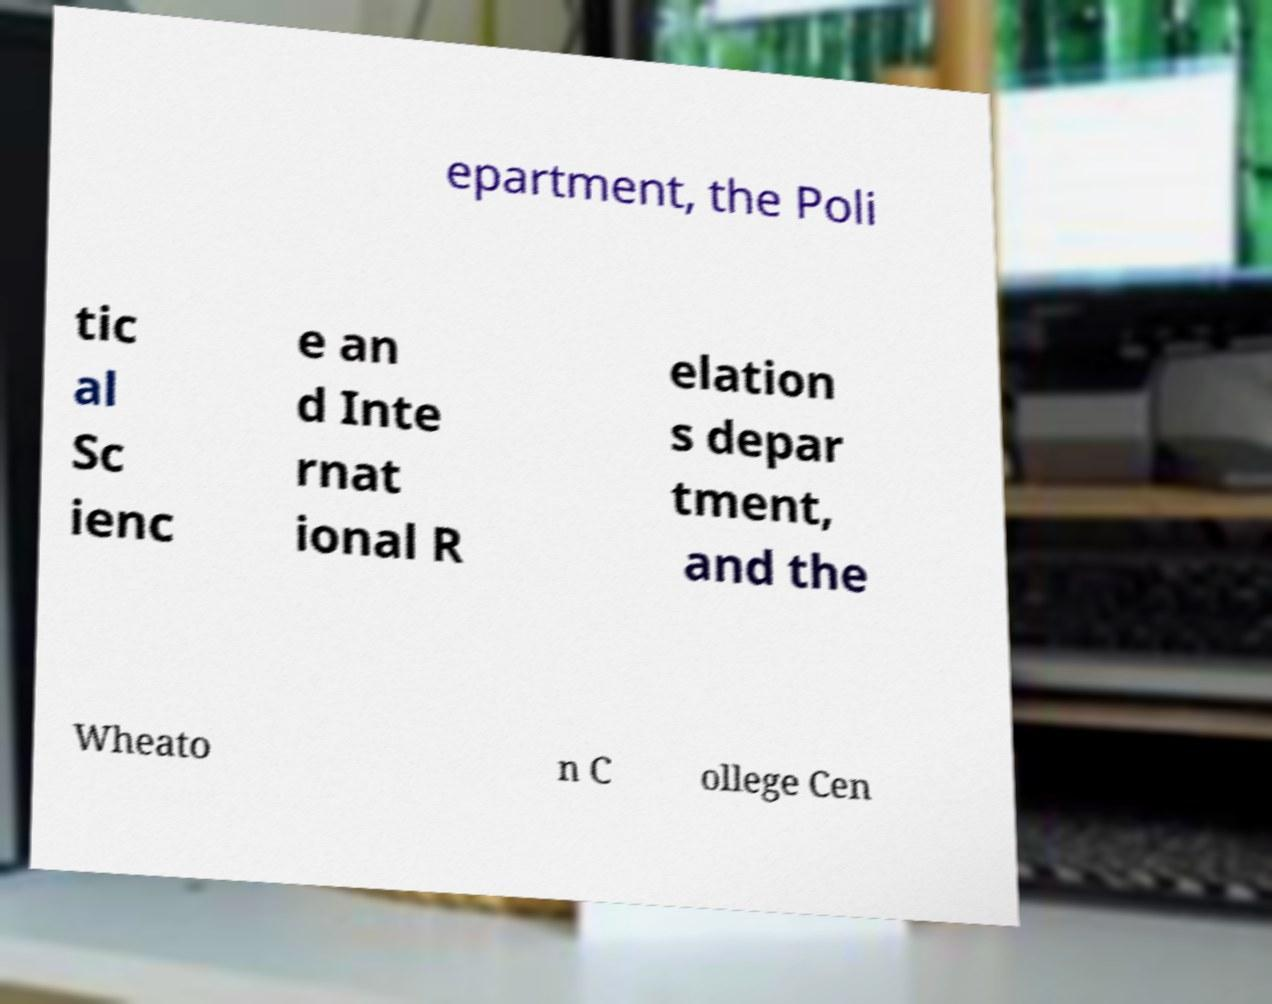I need the written content from this picture converted into text. Can you do that? epartment, the Poli tic al Sc ienc e an d Inte rnat ional R elation s depar tment, and the Wheato n C ollege Cen 